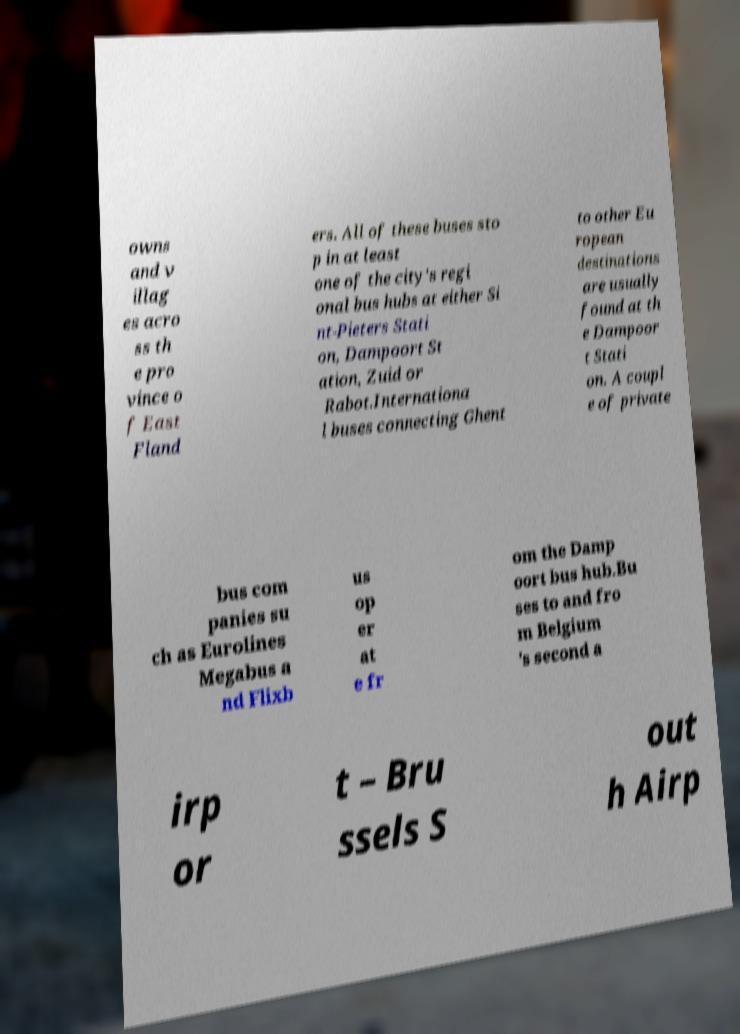There's text embedded in this image that I need extracted. Can you transcribe it verbatim? owns and v illag es acro ss th e pro vince o f East Fland ers. All of these buses sto p in at least one of the city's regi onal bus hubs at either Si nt-Pieters Stati on, Dampoort St ation, Zuid or Rabot.Internationa l buses connecting Ghent to other Eu ropean destinations are usually found at th e Dampoor t Stati on. A coupl e of private bus com panies su ch as Eurolines Megabus a nd Flixb us op er at e fr om the Damp oort bus hub.Bu ses to and fro m Belgium 's second a irp or t – Bru ssels S out h Airp 